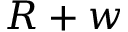<formula> <loc_0><loc_0><loc_500><loc_500>R + w</formula> 